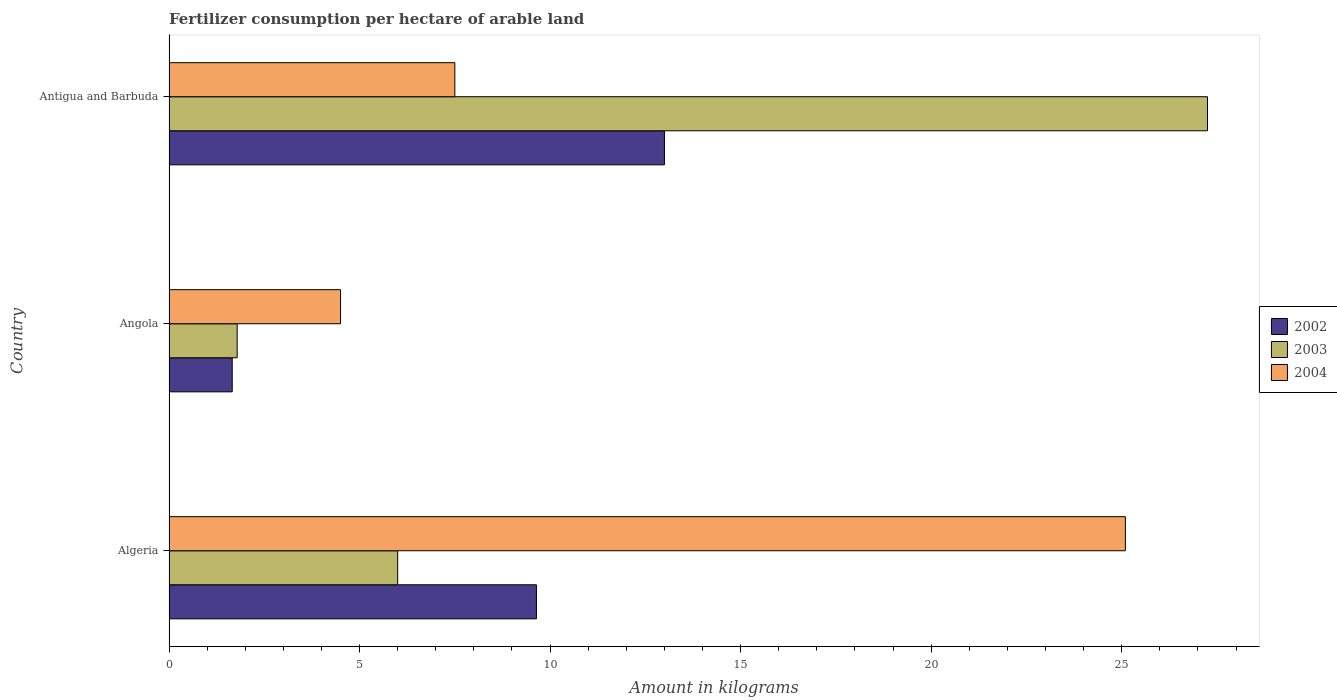How many different coloured bars are there?
Your answer should be compact. 3. How many groups of bars are there?
Make the answer very short. 3. Are the number of bars on each tick of the Y-axis equal?
Provide a succinct answer. Yes. What is the label of the 3rd group of bars from the top?
Ensure brevity in your answer.  Algeria. What is the amount of fertilizer consumption in 2002 in Algeria?
Offer a very short reply. 9.64. Across all countries, what is the maximum amount of fertilizer consumption in 2003?
Ensure brevity in your answer.  27.25. Across all countries, what is the minimum amount of fertilizer consumption in 2004?
Keep it short and to the point. 4.5. In which country was the amount of fertilizer consumption in 2004 maximum?
Provide a short and direct response. Algeria. In which country was the amount of fertilizer consumption in 2004 minimum?
Your answer should be very brief. Angola. What is the total amount of fertilizer consumption in 2002 in the graph?
Give a very brief answer. 24.3. What is the difference between the amount of fertilizer consumption in 2003 in Algeria and that in Angola?
Your answer should be very brief. 4.21. What is the difference between the amount of fertilizer consumption in 2003 in Antigua and Barbuda and the amount of fertilizer consumption in 2004 in Angola?
Offer a very short reply. 22.75. What is the average amount of fertilizer consumption in 2002 per country?
Provide a short and direct response. 8.1. What is the difference between the amount of fertilizer consumption in 2004 and amount of fertilizer consumption in 2003 in Angola?
Offer a terse response. 2.71. In how many countries, is the amount of fertilizer consumption in 2004 greater than 19 kg?
Keep it short and to the point. 1. What is the ratio of the amount of fertilizer consumption in 2004 in Algeria to that in Antigua and Barbuda?
Ensure brevity in your answer.  3.35. Is the amount of fertilizer consumption in 2003 in Algeria less than that in Antigua and Barbuda?
Ensure brevity in your answer.  Yes. What is the difference between the highest and the second highest amount of fertilizer consumption in 2002?
Your answer should be very brief. 3.36. What is the difference between the highest and the lowest amount of fertilizer consumption in 2004?
Provide a short and direct response. 20.59. What does the 2nd bar from the top in Angola represents?
Your answer should be compact. 2003. What does the 1st bar from the bottom in Algeria represents?
Ensure brevity in your answer.  2002. Is it the case that in every country, the sum of the amount of fertilizer consumption in 2003 and amount of fertilizer consumption in 2002 is greater than the amount of fertilizer consumption in 2004?
Make the answer very short. No. How many bars are there?
Your response must be concise. 9. Are all the bars in the graph horizontal?
Provide a short and direct response. Yes. What is the difference between two consecutive major ticks on the X-axis?
Offer a very short reply. 5. Are the values on the major ticks of X-axis written in scientific E-notation?
Your answer should be very brief. No. Does the graph contain grids?
Make the answer very short. No. Where does the legend appear in the graph?
Offer a terse response. Center right. How many legend labels are there?
Your answer should be very brief. 3. How are the legend labels stacked?
Your answer should be compact. Vertical. What is the title of the graph?
Provide a succinct answer. Fertilizer consumption per hectare of arable land. What is the label or title of the X-axis?
Provide a succinct answer. Amount in kilograms. What is the Amount in kilograms of 2002 in Algeria?
Your response must be concise. 9.64. What is the Amount in kilograms in 2003 in Algeria?
Your answer should be very brief. 6. What is the Amount in kilograms of 2004 in Algeria?
Your answer should be very brief. 25.1. What is the Amount in kilograms in 2002 in Angola?
Give a very brief answer. 1.66. What is the Amount in kilograms of 2003 in Angola?
Make the answer very short. 1.79. What is the Amount in kilograms in 2004 in Angola?
Keep it short and to the point. 4.5. What is the Amount in kilograms in 2003 in Antigua and Barbuda?
Your answer should be compact. 27.25. Across all countries, what is the maximum Amount in kilograms of 2003?
Keep it short and to the point. 27.25. Across all countries, what is the maximum Amount in kilograms in 2004?
Ensure brevity in your answer.  25.1. Across all countries, what is the minimum Amount in kilograms of 2002?
Offer a very short reply. 1.66. Across all countries, what is the minimum Amount in kilograms in 2003?
Offer a terse response. 1.79. Across all countries, what is the minimum Amount in kilograms of 2004?
Your response must be concise. 4.5. What is the total Amount in kilograms in 2002 in the graph?
Offer a terse response. 24.3. What is the total Amount in kilograms in 2003 in the graph?
Ensure brevity in your answer.  35.04. What is the total Amount in kilograms of 2004 in the graph?
Ensure brevity in your answer.  37.1. What is the difference between the Amount in kilograms of 2002 in Algeria and that in Angola?
Offer a very short reply. 7.98. What is the difference between the Amount in kilograms in 2003 in Algeria and that in Angola?
Your response must be concise. 4.21. What is the difference between the Amount in kilograms in 2004 in Algeria and that in Angola?
Provide a succinct answer. 20.59. What is the difference between the Amount in kilograms of 2002 in Algeria and that in Antigua and Barbuda?
Your answer should be compact. -3.36. What is the difference between the Amount in kilograms in 2003 in Algeria and that in Antigua and Barbuda?
Offer a terse response. -21.25. What is the difference between the Amount in kilograms in 2004 in Algeria and that in Antigua and Barbuda?
Your response must be concise. 17.6. What is the difference between the Amount in kilograms of 2002 in Angola and that in Antigua and Barbuda?
Your answer should be very brief. -11.34. What is the difference between the Amount in kilograms in 2003 in Angola and that in Antigua and Barbuda?
Your answer should be compact. -25.46. What is the difference between the Amount in kilograms of 2004 in Angola and that in Antigua and Barbuda?
Your answer should be very brief. -3. What is the difference between the Amount in kilograms of 2002 in Algeria and the Amount in kilograms of 2003 in Angola?
Your answer should be compact. 7.85. What is the difference between the Amount in kilograms of 2002 in Algeria and the Amount in kilograms of 2004 in Angola?
Ensure brevity in your answer.  5.14. What is the difference between the Amount in kilograms of 2003 in Algeria and the Amount in kilograms of 2004 in Angola?
Your answer should be compact. 1.5. What is the difference between the Amount in kilograms of 2002 in Algeria and the Amount in kilograms of 2003 in Antigua and Barbuda?
Make the answer very short. -17.61. What is the difference between the Amount in kilograms in 2002 in Algeria and the Amount in kilograms in 2004 in Antigua and Barbuda?
Keep it short and to the point. 2.14. What is the difference between the Amount in kilograms in 2003 in Algeria and the Amount in kilograms in 2004 in Antigua and Barbuda?
Provide a succinct answer. -1.5. What is the difference between the Amount in kilograms of 2002 in Angola and the Amount in kilograms of 2003 in Antigua and Barbuda?
Keep it short and to the point. -25.59. What is the difference between the Amount in kilograms in 2002 in Angola and the Amount in kilograms in 2004 in Antigua and Barbuda?
Your answer should be very brief. -5.84. What is the difference between the Amount in kilograms of 2003 in Angola and the Amount in kilograms of 2004 in Antigua and Barbuda?
Provide a succinct answer. -5.71. What is the average Amount in kilograms of 2002 per country?
Ensure brevity in your answer.  8.1. What is the average Amount in kilograms in 2003 per country?
Keep it short and to the point. 11.68. What is the average Amount in kilograms of 2004 per country?
Make the answer very short. 12.37. What is the difference between the Amount in kilograms in 2002 and Amount in kilograms in 2003 in Algeria?
Offer a very short reply. 3.64. What is the difference between the Amount in kilograms of 2002 and Amount in kilograms of 2004 in Algeria?
Provide a short and direct response. -15.45. What is the difference between the Amount in kilograms of 2003 and Amount in kilograms of 2004 in Algeria?
Your response must be concise. -19.09. What is the difference between the Amount in kilograms in 2002 and Amount in kilograms in 2003 in Angola?
Give a very brief answer. -0.13. What is the difference between the Amount in kilograms of 2002 and Amount in kilograms of 2004 in Angola?
Your answer should be very brief. -2.84. What is the difference between the Amount in kilograms of 2003 and Amount in kilograms of 2004 in Angola?
Your answer should be compact. -2.71. What is the difference between the Amount in kilograms of 2002 and Amount in kilograms of 2003 in Antigua and Barbuda?
Give a very brief answer. -14.25. What is the difference between the Amount in kilograms of 2003 and Amount in kilograms of 2004 in Antigua and Barbuda?
Your answer should be very brief. 19.75. What is the ratio of the Amount in kilograms of 2002 in Algeria to that in Angola?
Offer a very short reply. 5.81. What is the ratio of the Amount in kilograms in 2003 in Algeria to that in Angola?
Keep it short and to the point. 3.35. What is the ratio of the Amount in kilograms in 2004 in Algeria to that in Angola?
Offer a terse response. 5.57. What is the ratio of the Amount in kilograms of 2002 in Algeria to that in Antigua and Barbuda?
Give a very brief answer. 0.74. What is the ratio of the Amount in kilograms of 2003 in Algeria to that in Antigua and Barbuda?
Your answer should be compact. 0.22. What is the ratio of the Amount in kilograms in 2004 in Algeria to that in Antigua and Barbuda?
Ensure brevity in your answer.  3.35. What is the ratio of the Amount in kilograms in 2002 in Angola to that in Antigua and Barbuda?
Make the answer very short. 0.13. What is the ratio of the Amount in kilograms in 2003 in Angola to that in Antigua and Barbuda?
Ensure brevity in your answer.  0.07. What is the ratio of the Amount in kilograms in 2004 in Angola to that in Antigua and Barbuda?
Give a very brief answer. 0.6. What is the difference between the highest and the second highest Amount in kilograms of 2002?
Give a very brief answer. 3.36. What is the difference between the highest and the second highest Amount in kilograms of 2003?
Offer a terse response. 21.25. What is the difference between the highest and the second highest Amount in kilograms of 2004?
Provide a short and direct response. 17.6. What is the difference between the highest and the lowest Amount in kilograms of 2002?
Provide a short and direct response. 11.34. What is the difference between the highest and the lowest Amount in kilograms of 2003?
Your answer should be very brief. 25.46. What is the difference between the highest and the lowest Amount in kilograms of 2004?
Ensure brevity in your answer.  20.59. 